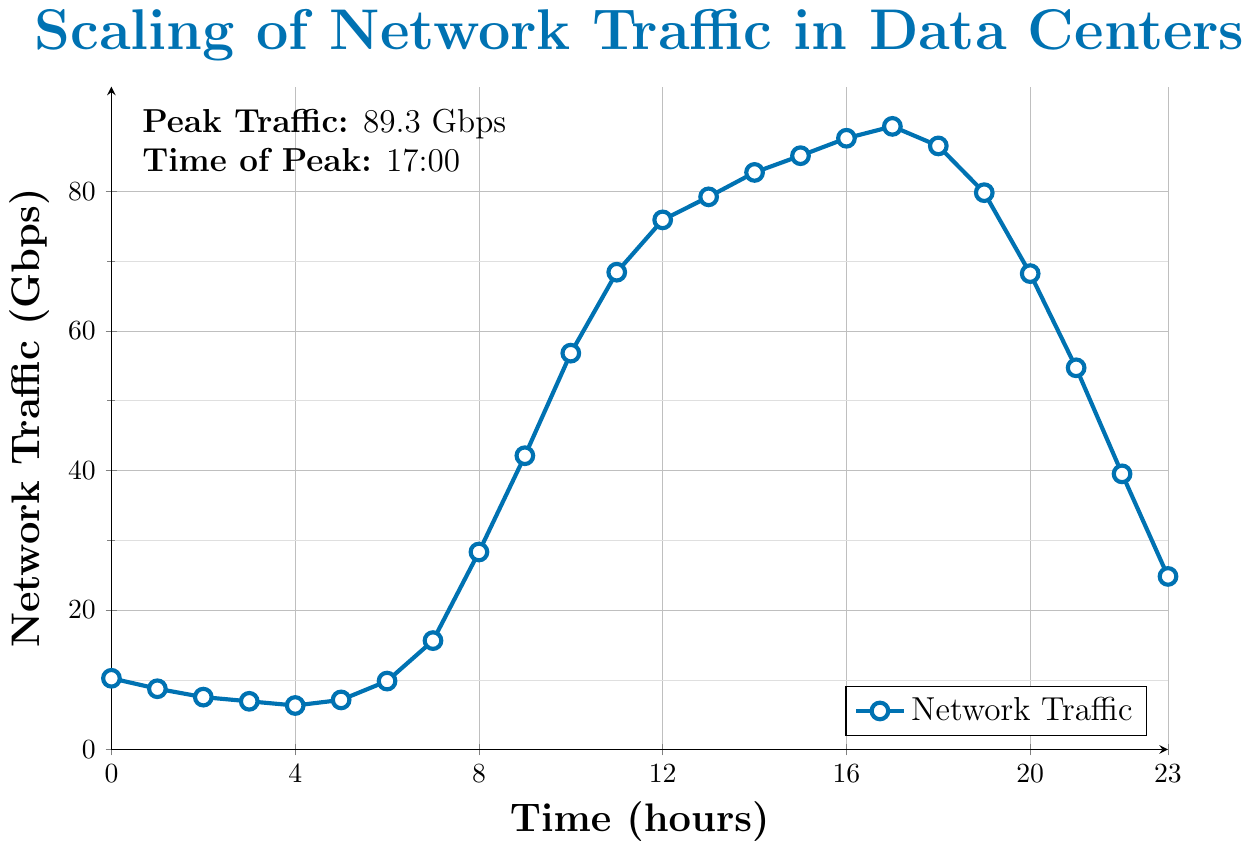What time of day does network traffic peak? The figure shows a highlighted note indicating the highest network traffic. The peak occurs at 17:00 with a traffic of 89.3 Gbps.
Answer: 17:00 What is the network traffic at 10:00 compared to at 20:00? At 10:00, the traffic is shown to be 56.8 Gbps, and at 20:00, it drops to 68.2 Gbps.
Answer: 56.8 Gbps and 68.2 Gbps During which hours is the network traffic increasing continuously? From the figure, the traffic increases from 3:00 to 7:00 and then from 8:00 to 17:00.
Answer: 3:00-7:00 and 8:00-17:00 What is the difference in network traffic between 8:00 and 12:00? At 8:00, the traffic is 28.3 Gbps, and at 12:00, it is 75.9 Gbps. The difference is 75.9 - 28.3 = 47.6 Gbps.
Answer: 47.6 Gbps During which hour is there the steepest increase in network traffic? Observing the steepness of the curves, the largest increase occurs between 8:00 and 9:00, where the traffic increases from 28.3 Gbps to 42.1 Gbps.
Answer: 8:00-9:00 At what time does the network traffic start to decline after reaching its peak? The figure shows that the peak is at 17:00, and the traffic begins to decline right after at 18:00.
Answer: 18:00 Calculate the average network traffic from 0:00 to 4:00. The values from 0:00 to 4:00 are 10.2, 8.7, 7.5, 6.9, and 6.3. The average is (10.2 + 8.7 + 7.5 + 6.9 + 6.3)/5 = 39.6/5 ≈ 7.92 Gbps.
Answer: 7.92 Gbps By how much does the network traffic increase from 6:00 to 7:00? At 6:00, the traffic is 9.8 Gbps, and at 7:00, it rises to 15.6 Gbps. The increase is 15.6 - 9.8 = 5.8 Gbps.
Answer: 5.8 Gbps What is the total network traffic for the entire 24-hour period? Add all the traffic values given for each hour: 10.2 + 8.7 + 7.5 + 6.9 + 6.3 + 7.1 + 9.8 + 15.6 + 28.3 + 42.1 + 56.8 + 68.4 + 75.9 + 79.2 + 82.7 + 85.1 + 87.6 + 89.3 + 86.5 + 79.8 + 68.2 + 54.7 + 39.5 + 24.8 = 1032.9 Gbps.
Answer: 1032.9 Gbps 